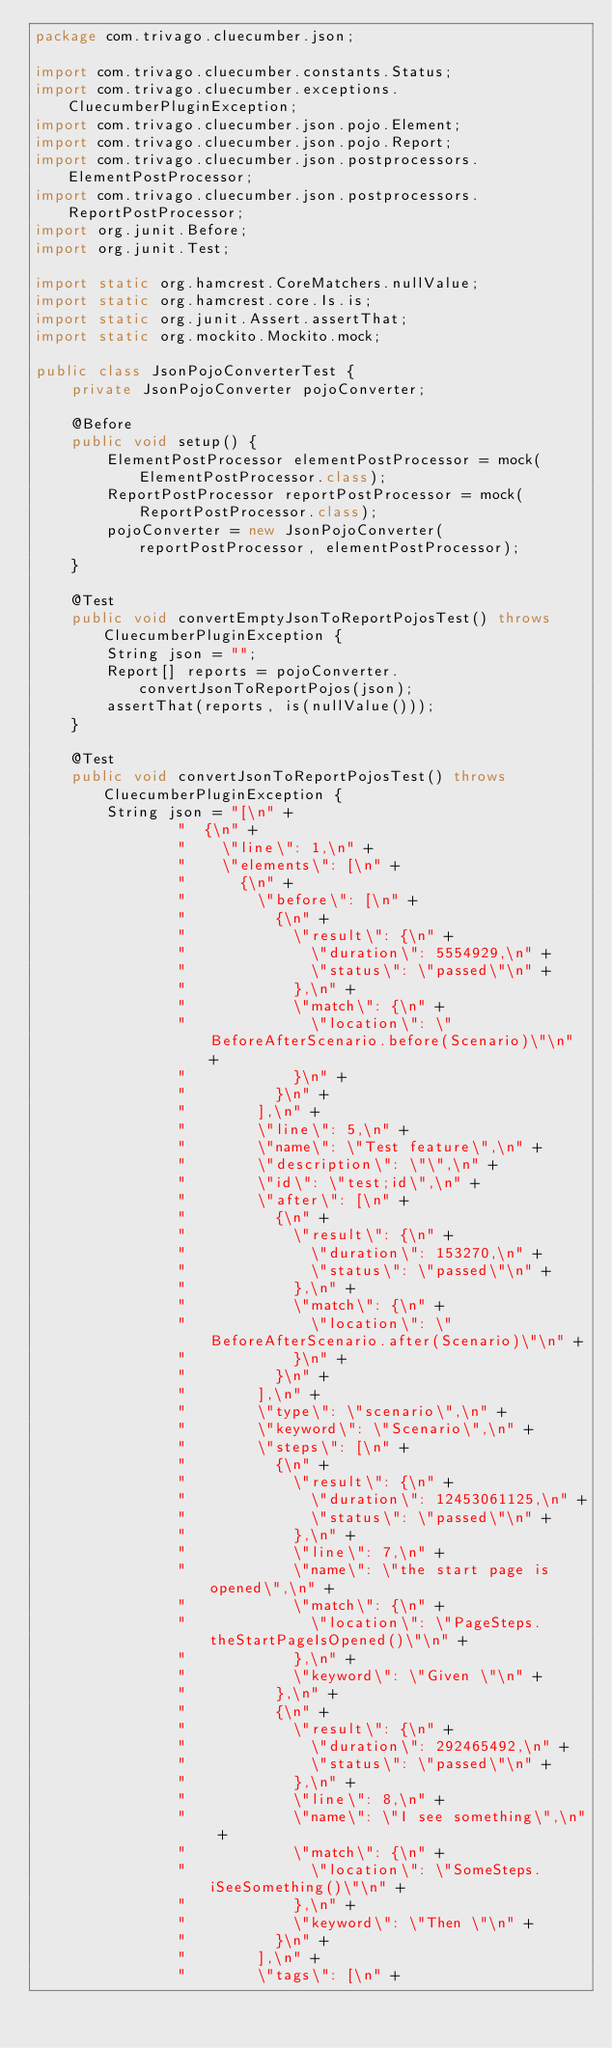<code> <loc_0><loc_0><loc_500><loc_500><_Java_>package com.trivago.cluecumber.json;

import com.trivago.cluecumber.constants.Status;
import com.trivago.cluecumber.exceptions.CluecumberPluginException;
import com.trivago.cluecumber.json.pojo.Element;
import com.trivago.cluecumber.json.pojo.Report;
import com.trivago.cluecumber.json.postprocessors.ElementPostProcessor;
import com.trivago.cluecumber.json.postprocessors.ReportPostProcessor;
import org.junit.Before;
import org.junit.Test;

import static org.hamcrest.CoreMatchers.nullValue;
import static org.hamcrest.core.Is.is;
import static org.junit.Assert.assertThat;
import static org.mockito.Mockito.mock;

public class JsonPojoConverterTest {
    private JsonPojoConverter pojoConverter;

    @Before
    public void setup() {
        ElementPostProcessor elementPostProcessor = mock(ElementPostProcessor.class);
        ReportPostProcessor reportPostProcessor = mock(ReportPostProcessor.class);
        pojoConverter = new JsonPojoConverter(reportPostProcessor, elementPostProcessor);
    }

    @Test
    public void convertEmptyJsonToReportPojosTest() throws CluecumberPluginException {
        String json = "";
        Report[] reports = pojoConverter.convertJsonToReportPojos(json);
        assertThat(reports, is(nullValue()));
    }

    @Test
    public void convertJsonToReportPojosTest() throws CluecumberPluginException {
        String json = "[\n" +
                "  {\n" +
                "    \"line\": 1,\n" +
                "    \"elements\": [\n" +
                "      {\n" +
                "        \"before\": [\n" +
                "          {\n" +
                "            \"result\": {\n" +
                "              \"duration\": 5554929,\n" +
                "              \"status\": \"passed\"\n" +
                "            },\n" +
                "            \"match\": {\n" +
                "              \"location\": \"BeforeAfterScenario.before(Scenario)\"\n" +
                "            }\n" +
                "          }\n" +
                "        ],\n" +
                "        \"line\": 5,\n" +
                "        \"name\": \"Test feature\",\n" +
                "        \"description\": \"\",\n" +
                "        \"id\": \"test;id\",\n" +
                "        \"after\": [\n" +
                "          {\n" +
                "            \"result\": {\n" +
                "              \"duration\": 153270,\n" +
                "              \"status\": \"passed\"\n" +
                "            },\n" +
                "            \"match\": {\n" +
                "              \"location\": \"BeforeAfterScenario.after(Scenario)\"\n" +
                "            }\n" +
                "          }\n" +
                "        ],\n" +
                "        \"type\": \"scenario\",\n" +
                "        \"keyword\": \"Scenario\",\n" +
                "        \"steps\": [\n" +
                "          {\n" +
                "            \"result\": {\n" +
                "              \"duration\": 12453061125,\n" +
                "              \"status\": \"passed\"\n" +
                "            },\n" +
                "            \"line\": 7,\n" +
                "            \"name\": \"the start page is opened\",\n" +
                "            \"match\": {\n" +
                "              \"location\": \"PageSteps.theStartPageIsOpened()\"\n" +
                "            },\n" +
                "            \"keyword\": \"Given \"\n" +
                "          },\n" +
                "          {\n" +
                "            \"result\": {\n" +
                "              \"duration\": 292465492,\n" +
                "              \"status\": \"passed\"\n" +
                "            },\n" +
                "            \"line\": 8,\n" +
                "            \"name\": \"I see something\",\n" +
                "            \"match\": {\n" +
                "              \"location\": \"SomeSteps.iSeeSomething()\"\n" +
                "            },\n" +
                "            \"keyword\": \"Then \"\n" +
                "          }\n" +
                "        ],\n" +
                "        \"tags\": [\n" +</code> 